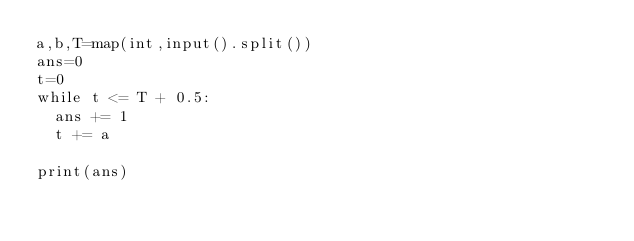Convert code to text. <code><loc_0><loc_0><loc_500><loc_500><_Python_>a,b,T=map(int,input().split())
ans=0
t=0
while t <= T + 0.5:
  ans += 1
  t += a
  
print(ans)</code> 